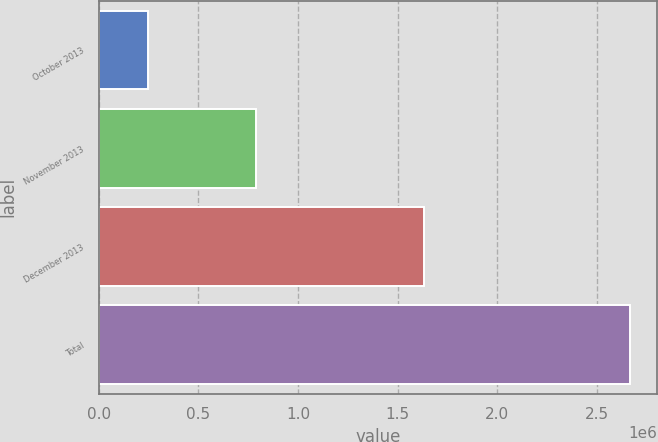<chart> <loc_0><loc_0><loc_500><loc_500><bar_chart><fcel>October 2013<fcel>November 2013<fcel>December 2013<fcel>Total<nl><fcel>245000<fcel>791099<fcel>1.63168e+06<fcel>2.66778e+06<nl></chart> 